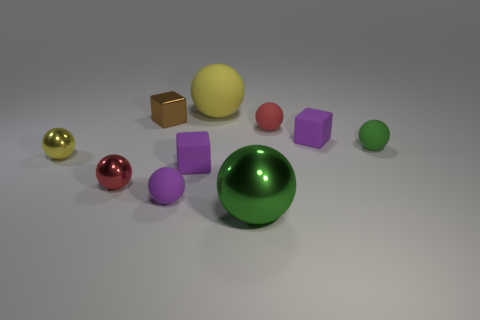Subtract all purple cubes. How many cubes are left? 1 Subtract all brown blocks. How many blocks are left? 2 Subtract all cubes. How many objects are left? 7 Subtract 3 blocks. How many blocks are left? 0 Subtract all yellow balls. How many purple blocks are left? 2 Add 3 brown matte balls. How many brown matte balls exist? 3 Subtract 0 red blocks. How many objects are left? 10 Subtract all gray balls. Subtract all cyan cubes. How many balls are left? 7 Subtract all tiny green spheres. Subtract all purple spheres. How many objects are left? 8 Add 1 red objects. How many red objects are left? 3 